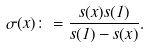<formula> <loc_0><loc_0><loc_500><loc_500>\sigma ( x ) \colon = \frac { s ( x ) s ( 1 ) } { s ( 1 ) - s ( x ) } .</formula> 